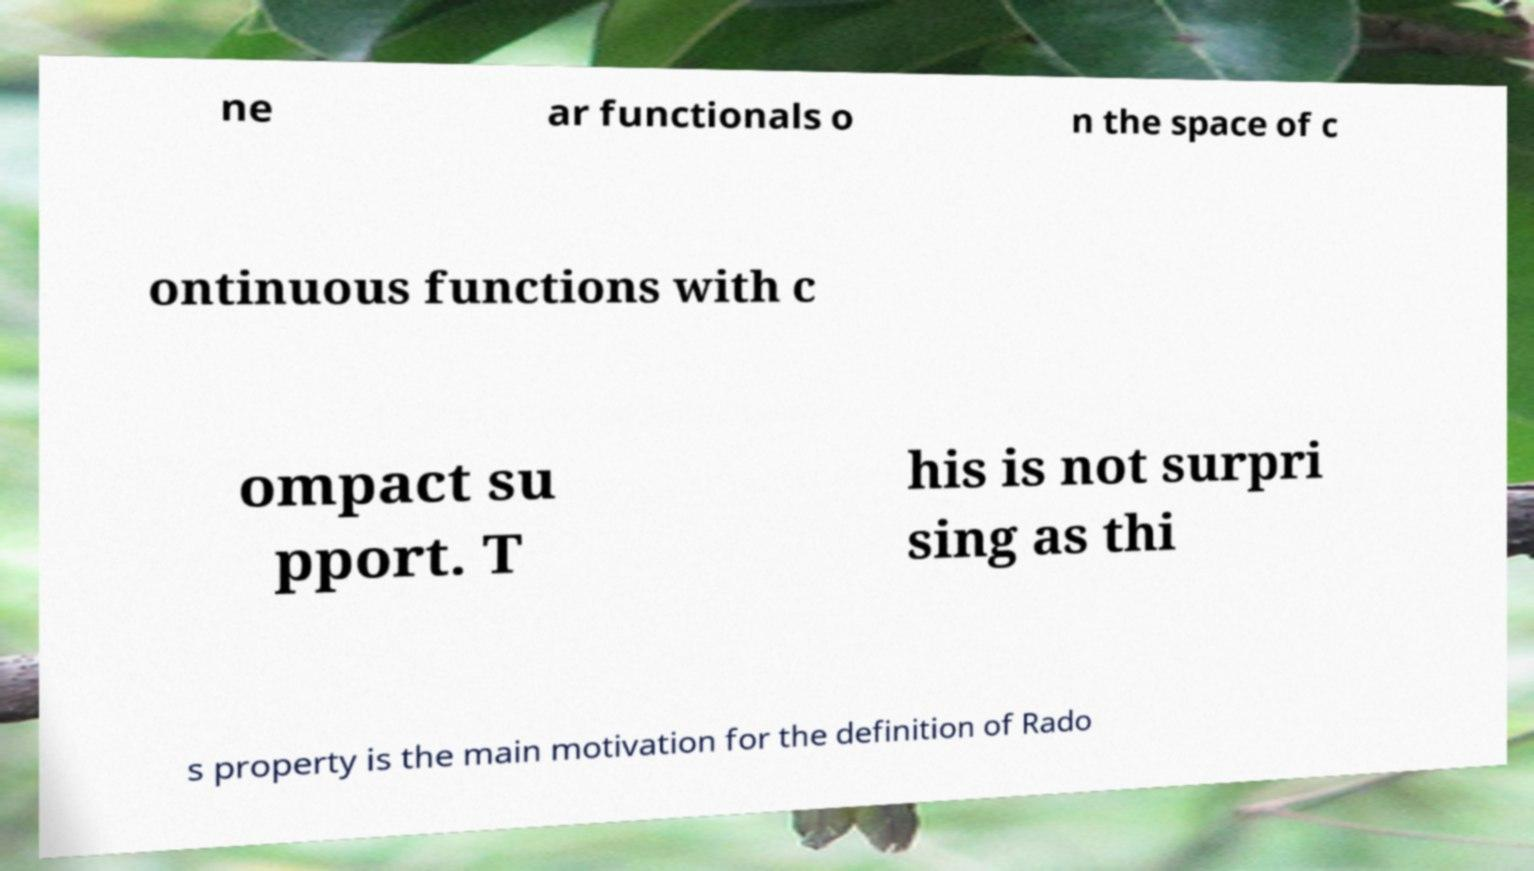Can you read and provide the text displayed in the image?This photo seems to have some interesting text. Can you extract and type it out for me? ne ar functionals o n the space of c ontinuous functions with c ompact su pport. T his is not surpri sing as thi s property is the main motivation for the definition of Rado 